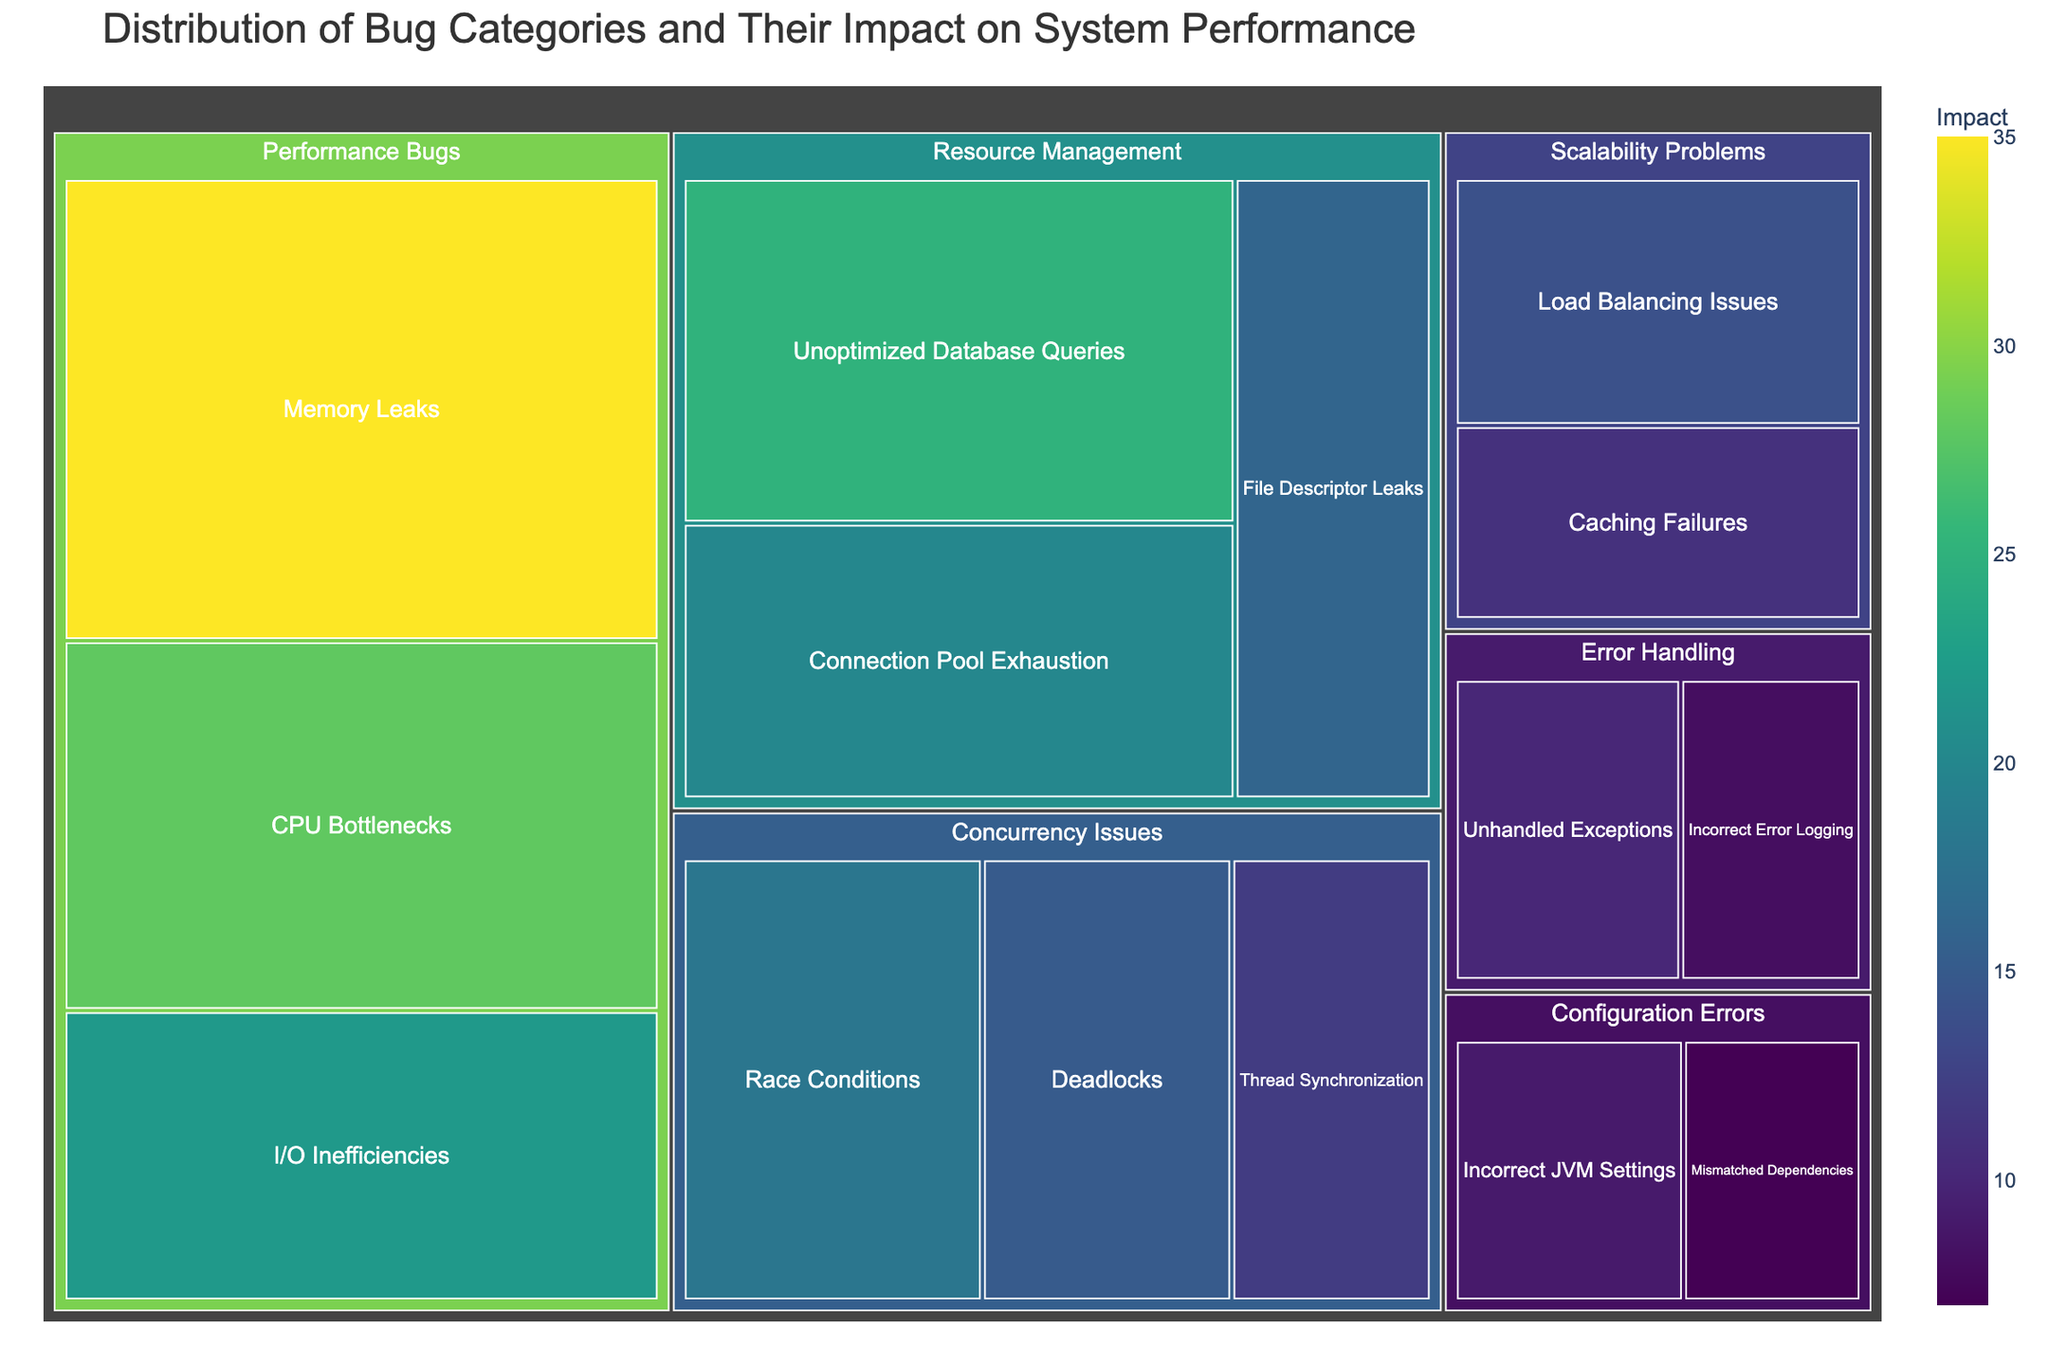What is the title of the treemap? The title of the treemap is displayed at the top of the figure. It is meant to provide an overview of what the treemap represents. The title reads: "Distribution of Bug Categories and Their Impact on System Performance".
Answer: Distribution of Bug Categories and Their Impact on System Performance Which subcategory under "Performance Bugs" has the highest impact? By looking at the size of the tiles under "Performance Bugs", we can see that "Memory Leaks" is the largest tile, indicating it has the highest impact with a value of 35.
Answer: Memory Leaks Which category has the highest total impact? To determine the category with the highest total impact, sum up the impact values for each subcategory in each category. "Performance Bugs" has the highest total impact because the sum of its subcategories is 35 (Memory Leaks) + 28 (CPU Bottlenecks) + 22 (I/O Inefficiencies) = 85.
Answer: Performance Bugs What is the combined impact of "Concurrency Issues"? Sum the impact values of all subcategories under "Concurrency Issues". The combined impact is 18 (Race Conditions) + 15 (Deadlocks) + 12 (Thread Synchronization) = 45.
Answer: 45 How does the impact of "Unoptimized Database Queries" compare to "Memory Leaks"? Compare the impact values of the two subcategories. "Memory Leaks" has an impact value of 35 and "Unoptimized Database Queries" has an impact of 25. Therefore, "Memory Leaks" has a higher impact than "Unoptimized Database Queries".
Answer: Memory Leaks has a higher impact What subcategory has the lowest impact in the "Error Handling" category? Within the "Error Handling" category, compare the sizes of the tiles. The "Incorrect Error Logging" subcategory has a value of 8, which is lower than "Unhandled Exceptions" with 10. Thus, "Incorrect Error Logging" has the lowest impact.
Answer: Incorrect Error Logging What is the total impact for the "Scalability Problems" category? Add the impact values of both subcategories under "Scalability Problems". The total impact is 14 (Load Balancing Issues) + 11 (Caching Failures) = 25.
Answer: 25 Among all subcategories, which one has the smallest impact? Identify the subcategory with the smallest size (indicating the lowest value). "Mismatched Dependencies" under "Configuration Errors" has the smallest impact with a value of 7.
Answer: Mismatched Dependencies 